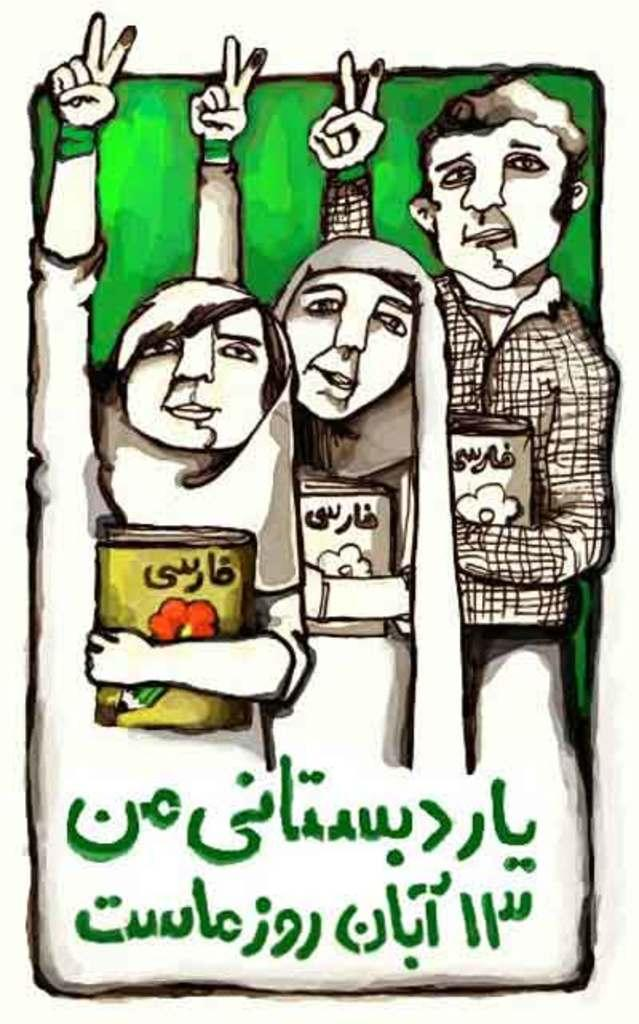What type of visual is the image? The image appears to be a poster. What are the persons in the poster doing? The persons in the poster are holding books. What color is the background of the poster? The background of the poster is in green color. Is there any text on the poster? Yes, there is some text at the bottom of the poster. Can you tell me how many firemen are depicted on the poster? There are no firemen depicted on the poster; it features persons holding books. What type of test is being conducted in the image? There is no test being conducted in the image; it is a poster with persons holding books and a green background. 